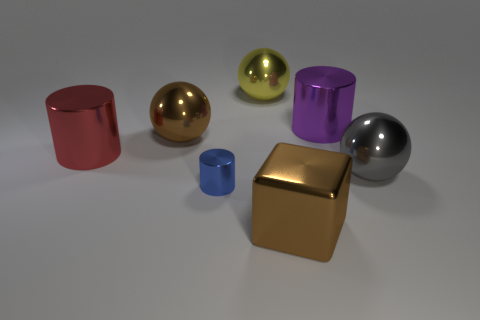Subtract all large metallic cylinders. How many cylinders are left? 1 Add 2 yellow balls. How many objects exist? 9 Subtract all cylinders. How many objects are left? 4 Subtract all cyan cylinders. Subtract all yellow balls. How many cylinders are left? 3 Add 2 purple objects. How many purple objects exist? 3 Subtract 0 green cubes. How many objects are left? 7 Subtract all small yellow shiny cubes. Subtract all brown shiny blocks. How many objects are left? 6 Add 6 blue objects. How many blue objects are left? 7 